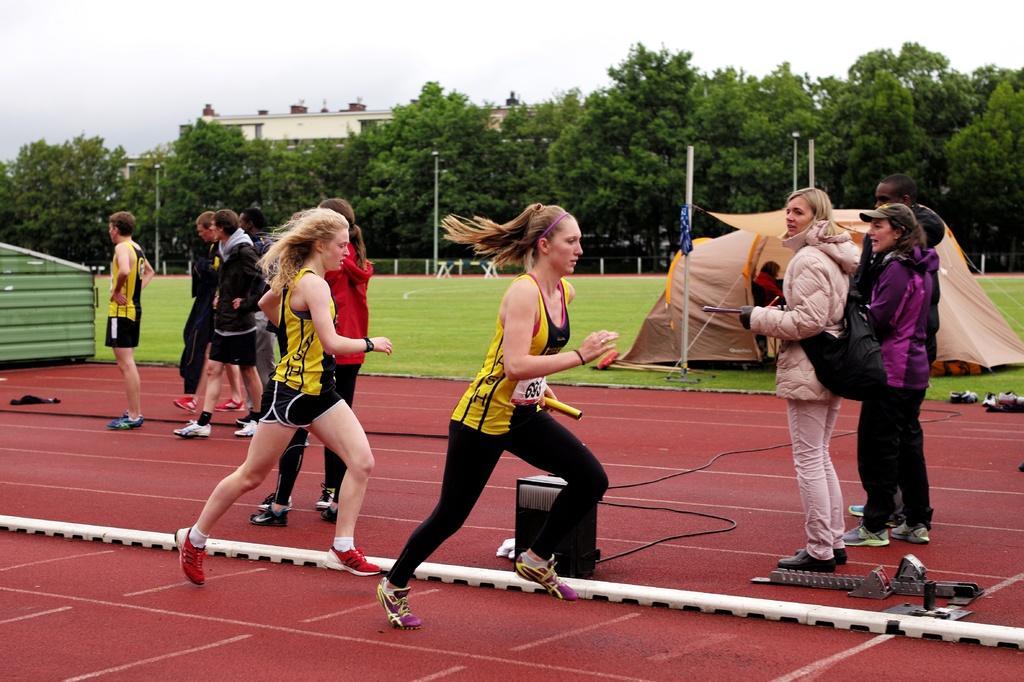How would you summarize this image in a sentence or two? In this image, we can two persons running on the track. There are some persons standing and wearing clothes. There is a tent on the right side of the image. There are some poles and trees in the middle of the image. There is a sky at the top of the image. 